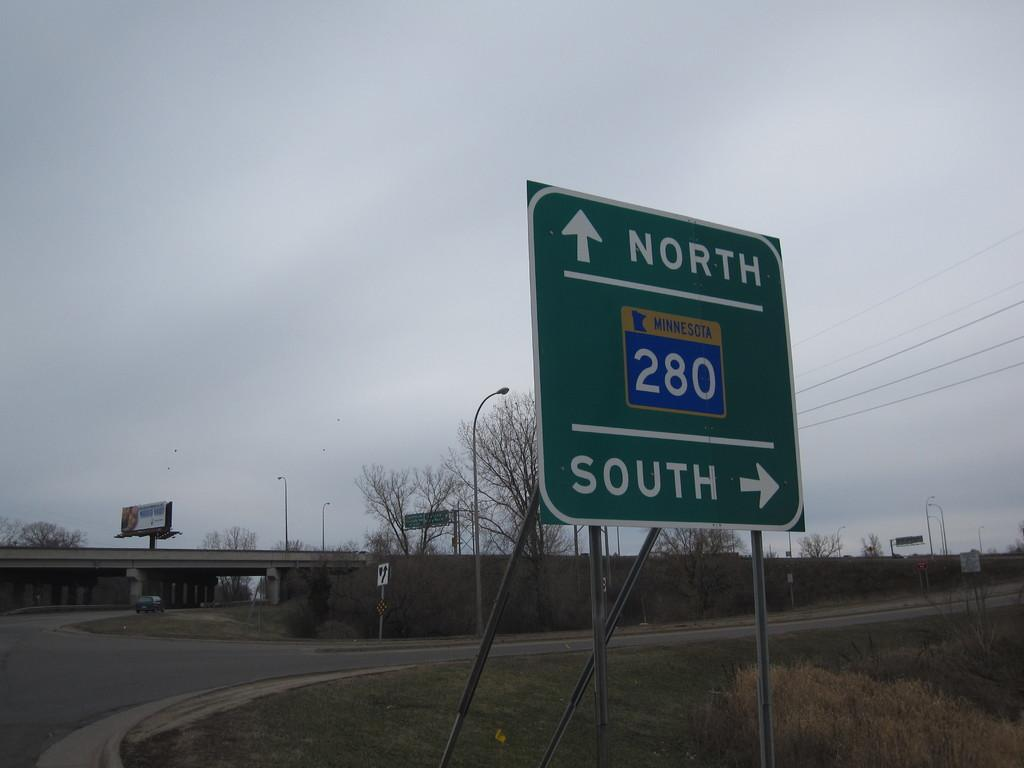<image>
Give a short and clear explanation of the subsequent image. A sign points in the direction of North and South. 